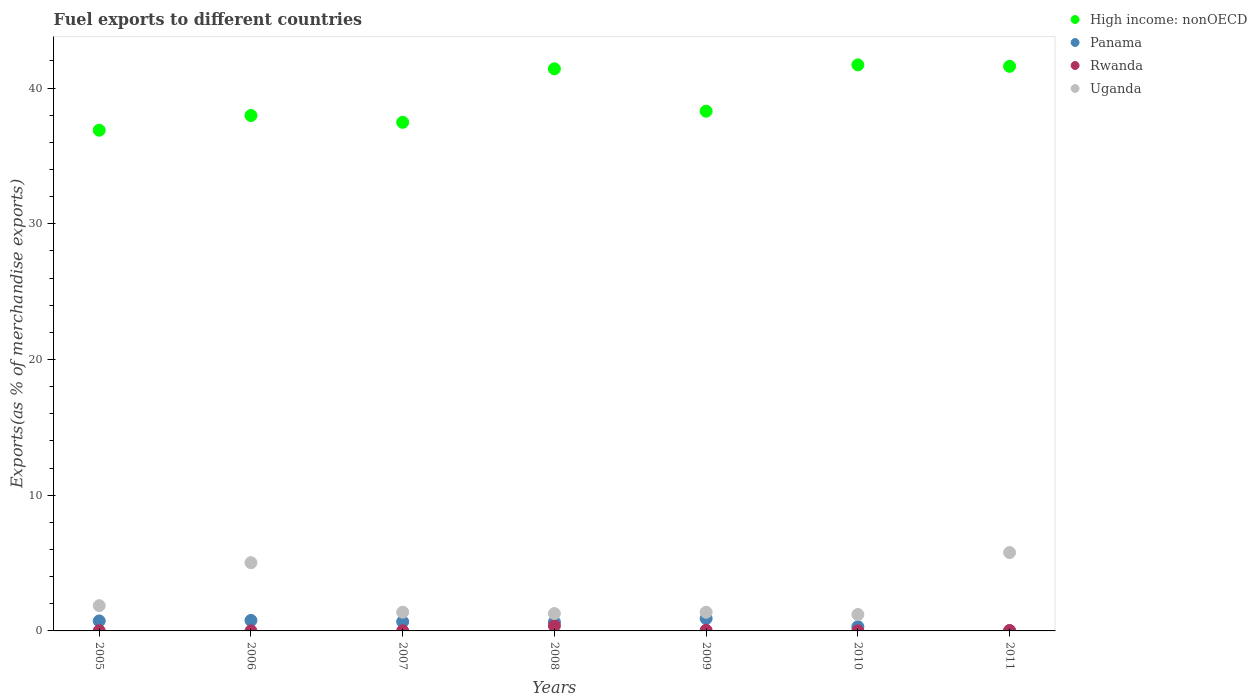What is the percentage of exports to different countries in Uganda in 2005?
Ensure brevity in your answer.  1.86. Across all years, what is the maximum percentage of exports to different countries in High income: nonOECD?
Provide a short and direct response. 41.71. Across all years, what is the minimum percentage of exports to different countries in Panama?
Give a very brief answer. 0.01. In which year was the percentage of exports to different countries in Panama maximum?
Offer a terse response. 2009. In which year was the percentage of exports to different countries in Rwanda minimum?
Provide a succinct answer. 2006. What is the total percentage of exports to different countries in Panama in the graph?
Offer a very short reply. 4.08. What is the difference between the percentage of exports to different countries in Panama in 2005 and that in 2006?
Offer a terse response. -0.04. What is the difference between the percentage of exports to different countries in High income: nonOECD in 2005 and the percentage of exports to different countries in Uganda in 2007?
Offer a terse response. 35.51. What is the average percentage of exports to different countries in Uganda per year?
Offer a very short reply. 2.56. In the year 2009, what is the difference between the percentage of exports to different countries in Panama and percentage of exports to different countries in Uganda?
Make the answer very short. -0.46. In how many years, is the percentage of exports to different countries in High income: nonOECD greater than 20 %?
Provide a succinct answer. 7. What is the ratio of the percentage of exports to different countries in Rwanda in 2007 to that in 2011?
Offer a terse response. 0.36. What is the difference between the highest and the second highest percentage of exports to different countries in Uganda?
Keep it short and to the point. 0.74. What is the difference between the highest and the lowest percentage of exports to different countries in High income: nonOECD?
Your response must be concise. 4.82. In how many years, is the percentage of exports to different countries in Rwanda greater than the average percentage of exports to different countries in Rwanda taken over all years?
Give a very brief answer. 1. Is the sum of the percentage of exports to different countries in High income: nonOECD in 2007 and 2011 greater than the maximum percentage of exports to different countries in Panama across all years?
Offer a terse response. Yes. Is it the case that in every year, the sum of the percentage of exports to different countries in Uganda and percentage of exports to different countries in High income: nonOECD  is greater than the sum of percentage of exports to different countries in Rwanda and percentage of exports to different countries in Panama?
Give a very brief answer. Yes. Does the percentage of exports to different countries in Panama monotonically increase over the years?
Provide a succinct answer. No. Is the percentage of exports to different countries in Rwanda strictly greater than the percentage of exports to different countries in High income: nonOECD over the years?
Your answer should be very brief. No. Is the percentage of exports to different countries in Uganda strictly less than the percentage of exports to different countries in Rwanda over the years?
Offer a very short reply. No. How many years are there in the graph?
Keep it short and to the point. 7. What is the difference between two consecutive major ticks on the Y-axis?
Provide a succinct answer. 10. Are the values on the major ticks of Y-axis written in scientific E-notation?
Make the answer very short. No. Does the graph contain any zero values?
Provide a short and direct response. No. How are the legend labels stacked?
Offer a very short reply. Vertical. What is the title of the graph?
Provide a succinct answer. Fuel exports to different countries. Does "St. Lucia" appear as one of the legend labels in the graph?
Give a very brief answer. No. What is the label or title of the X-axis?
Your response must be concise. Years. What is the label or title of the Y-axis?
Give a very brief answer. Exports(as % of merchandise exports). What is the Exports(as % of merchandise exports) of High income: nonOECD in 2005?
Make the answer very short. 36.89. What is the Exports(as % of merchandise exports) of Panama in 2005?
Give a very brief answer. 0.74. What is the Exports(as % of merchandise exports) in Rwanda in 2005?
Make the answer very short. 0.01. What is the Exports(as % of merchandise exports) of Uganda in 2005?
Offer a terse response. 1.86. What is the Exports(as % of merchandise exports) of High income: nonOECD in 2006?
Offer a terse response. 37.98. What is the Exports(as % of merchandise exports) in Panama in 2006?
Your answer should be compact. 0.77. What is the Exports(as % of merchandise exports) in Rwanda in 2006?
Offer a terse response. 0. What is the Exports(as % of merchandise exports) in Uganda in 2006?
Keep it short and to the point. 5.03. What is the Exports(as % of merchandise exports) in High income: nonOECD in 2007?
Your response must be concise. 37.48. What is the Exports(as % of merchandise exports) of Panama in 2007?
Provide a short and direct response. 0.68. What is the Exports(as % of merchandise exports) in Rwanda in 2007?
Your response must be concise. 0.01. What is the Exports(as % of merchandise exports) in Uganda in 2007?
Make the answer very short. 1.38. What is the Exports(as % of merchandise exports) in High income: nonOECD in 2008?
Keep it short and to the point. 41.42. What is the Exports(as % of merchandise exports) of Panama in 2008?
Offer a very short reply. 0.65. What is the Exports(as % of merchandise exports) of Rwanda in 2008?
Provide a succinct answer. 0.37. What is the Exports(as % of merchandise exports) in Uganda in 2008?
Keep it short and to the point. 1.28. What is the Exports(as % of merchandise exports) of High income: nonOECD in 2009?
Provide a succinct answer. 38.29. What is the Exports(as % of merchandise exports) of Panama in 2009?
Your answer should be very brief. 0.91. What is the Exports(as % of merchandise exports) in Rwanda in 2009?
Ensure brevity in your answer.  0.05. What is the Exports(as % of merchandise exports) of Uganda in 2009?
Keep it short and to the point. 1.38. What is the Exports(as % of merchandise exports) of High income: nonOECD in 2010?
Give a very brief answer. 41.71. What is the Exports(as % of merchandise exports) in Panama in 2010?
Provide a short and direct response. 0.31. What is the Exports(as % of merchandise exports) of Rwanda in 2010?
Keep it short and to the point. 0.01. What is the Exports(as % of merchandise exports) of Uganda in 2010?
Ensure brevity in your answer.  1.21. What is the Exports(as % of merchandise exports) of High income: nonOECD in 2011?
Your answer should be compact. 41.6. What is the Exports(as % of merchandise exports) of Panama in 2011?
Provide a short and direct response. 0.01. What is the Exports(as % of merchandise exports) in Rwanda in 2011?
Provide a succinct answer. 0.03. What is the Exports(as % of merchandise exports) in Uganda in 2011?
Ensure brevity in your answer.  5.77. Across all years, what is the maximum Exports(as % of merchandise exports) in High income: nonOECD?
Provide a short and direct response. 41.71. Across all years, what is the maximum Exports(as % of merchandise exports) in Panama?
Your response must be concise. 0.91. Across all years, what is the maximum Exports(as % of merchandise exports) of Rwanda?
Your response must be concise. 0.37. Across all years, what is the maximum Exports(as % of merchandise exports) of Uganda?
Ensure brevity in your answer.  5.77. Across all years, what is the minimum Exports(as % of merchandise exports) of High income: nonOECD?
Your answer should be very brief. 36.89. Across all years, what is the minimum Exports(as % of merchandise exports) in Panama?
Provide a succinct answer. 0.01. Across all years, what is the minimum Exports(as % of merchandise exports) of Rwanda?
Provide a succinct answer. 0. Across all years, what is the minimum Exports(as % of merchandise exports) in Uganda?
Give a very brief answer. 1.21. What is the total Exports(as % of merchandise exports) of High income: nonOECD in the graph?
Offer a terse response. 275.36. What is the total Exports(as % of merchandise exports) in Panama in the graph?
Your answer should be compact. 4.08. What is the total Exports(as % of merchandise exports) in Rwanda in the graph?
Keep it short and to the point. 0.48. What is the total Exports(as % of merchandise exports) of Uganda in the graph?
Your response must be concise. 17.91. What is the difference between the Exports(as % of merchandise exports) in High income: nonOECD in 2005 and that in 2006?
Offer a terse response. -1.08. What is the difference between the Exports(as % of merchandise exports) in Panama in 2005 and that in 2006?
Give a very brief answer. -0.04. What is the difference between the Exports(as % of merchandise exports) of Rwanda in 2005 and that in 2006?
Provide a short and direct response. 0.01. What is the difference between the Exports(as % of merchandise exports) in Uganda in 2005 and that in 2006?
Offer a very short reply. -3.17. What is the difference between the Exports(as % of merchandise exports) of High income: nonOECD in 2005 and that in 2007?
Offer a very short reply. -0.58. What is the difference between the Exports(as % of merchandise exports) in Panama in 2005 and that in 2007?
Ensure brevity in your answer.  0.06. What is the difference between the Exports(as % of merchandise exports) in Rwanda in 2005 and that in 2007?
Offer a terse response. 0. What is the difference between the Exports(as % of merchandise exports) in Uganda in 2005 and that in 2007?
Make the answer very short. 0.48. What is the difference between the Exports(as % of merchandise exports) in High income: nonOECD in 2005 and that in 2008?
Your answer should be compact. -4.52. What is the difference between the Exports(as % of merchandise exports) in Panama in 2005 and that in 2008?
Make the answer very short. 0.09. What is the difference between the Exports(as % of merchandise exports) of Rwanda in 2005 and that in 2008?
Provide a short and direct response. -0.36. What is the difference between the Exports(as % of merchandise exports) of Uganda in 2005 and that in 2008?
Your answer should be compact. 0.58. What is the difference between the Exports(as % of merchandise exports) of High income: nonOECD in 2005 and that in 2009?
Offer a very short reply. -1.4. What is the difference between the Exports(as % of merchandise exports) of Panama in 2005 and that in 2009?
Your response must be concise. -0.18. What is the difference between the Exports(as % of merchandise exports) in Rwanda in 2005 and that in 2009?
Provide a succinct answer. -0.03. What is the difference between the Exports(as % of merchandise exports) of Uganda in 2005 and that in 2009?
Your response must be concise. 0.49. What is the difference between the Exports(as % of merchandise exports) of High income: nonOECD in 2005 and that in 2010?
Provide a short and direct response. -4.82. What is the difference between the Exports(as % of merchandise exports) of Panama in 2005 and that in 2010?
Your response must be concise. 0.42. What is the difference between the Exports(as % of merchandise exports) of Rwanda in 2005 and that in 2010?
Make the answer very short. 0.01. What is the difference between the Exports(as % of merchandise exports) of Uganda in 2005 and that in 2010?
Give a very brief answer. 0.65. What is the difference between the Exports(as % of merchandise exports) in High income: nonOECD in 2005 and that in 2011?
Provide a short and direct response. -4.71. What is the difference between the Exports(as % of merchandise exports) of Panama in 2005 and that in 2011?
Offer a very short reply. 0.72. What is the difference between the Exports(as % of merchandise exports) in Rwanda in 2005 and that in 2011?
Provide a short and direct response. -0.02. What is the difference between the Exports(as % of merchandise exports) of Uganda in 2005 and that in 2011?
Keep it short and to the point. -3.91. What is the difference between the Exports(as % of merchandise exports) in High income: nonOECD in 2006 and that in 2007?
Give a very brief answer. 0.5. What is the difference between the Exports(as % of merchandise exports) in Panama in 2006 and that in 2007?
Offer a terse response. 0.09. What is the difference between the Exports(as % of merchandise exports) of Rwanda in 2006 and that in 2007?
Your answer should be very brief. -0.01. What is the difference between the Exports(as % of merchandise exports) in Uganda in 2006 and that in 2007?
Your answer should be very brief. 3.65. What is the difference between the Exports(as % of merchandise exports) of High income: nonOECD in 2006 and that in 2008?
Your answer should be compact. -3.44. What is the difference between the Exports(as % of merchandise exports) of Panama in 2006 and that in 2008?
Your answer should be very brief. 0.12. What is the difference between the Exports(as % of merchandise exports) in Rwanda in 2006 and that in 2008?
Keep it short and to the point. -0.37. What is the difference between the Exports(as % of merchandise exports) in Uganda in 2006 and that in 2008?
Provide a succinct answer. 3.75. What is the difference between the Exports(as % of merchandise exports) in High income: nonOECD in 2006 and that in 2009?
Provide a succinct answer. -0.32. What is the difference between the Exports(as % of merchandise exports) in Panama in 2006 and that in 2009?
Your response must be concise. -0.14. What is the difference between the Exports(as % of merchandise exports) of Rwanda in 2006 and that in 2009?
Keep it short and to the point. -0.04. What is the difference between the Exports(as % of merchandise exports) of Uganda in 2006 and that in 2009?
Your answer should be compact. 3.65. What is the difference between the Exports(as % of merchandise exports) in High income: nonOECD in 2006 and that in 2010?
Your answer should be compact. -3.73. What is the difference between the Exports(as % of merchandise exports) in Panama in 2006 and that in 2010?
Offer a very short reply. 0.46. What is the difference between the Exports(as % of merchandise exports) in Rwanda in 2006 and that in 2010?
Provide a succinct answer. -0. What is the difference between the Exports(as % of merchandise exports) of Uganda in 2006 and that in 2010?
Provide a short and direct response. 3.82. What is the difference between the Exports(as % of merchandise exports) in High income: nonOECD in 2006 and that in 2011?
Your answer should be compact. -3.62. What is the difference between the Exports(as % of merchandise exports) of Panama in 2006 and that in 2011?
Your answer should be very brief. 0.76. What is the difference between the Exports(as % of merchandise exports) of Rwanda in 2006 and that in 2011?
Make the answer very short. -0.03. What is the difference between the Exports(as % of merchandise exports) of Uganda in 2006 and that in 2011?
Your response must be concise. -0.74. What is the difference between the Exports(as % of merchandise exports) of High income: nonOECD in 2007 and that in 2008?
Your answer should be compact. -3.94. What is the difference between the Exports(as % of merchandise exports) of Panama in 2007 and that in 2008?
Offer a terse response. 0.03. What is the difference between the Exports(as % of merchandise exports) in Rwanda in 2007 and that in 2008?
Make the answer very short. -0.36. What is the difference between the Exports(as % of merchandise exports) in Uganda in 2007 and that in 2008?
Your response must be concise. 0.1. What is the difference between the Exports(as % of merchandise exports) of High income: nonOECD in 2007 and that in 2009?
Keep it short and to the point. -0.82. What is the difference between the Exports(as % of merchandise exports) in Panama in 2007 and that in 2009?
Provide a short and direct response. -0.23. What is the difference between the Exports(as % of merchandise exports) in Rwanda in 2007 and that in 2009?
Keep it short and to the point. -0.04. What is the difference between the Exports(as % of merchandise exports) of Uganda in 2007 and that in 2009?
Keep it short and to the point. 0. What is the difference between the Exports(as % of merchandise exports) of High income: nonOECD in 2007 and that in 2010?
Make the answer very short. -4.23. What is the difference between the Exports(as % of merchandise exports) of Panama in 2007 and that in 2010?
Offer a very short reply. 0.37. What is the difference between the Exports(as % of merchandise exports) in Rwanda in 2007 and that in 2010?
Offer a very short reply. 0.01. What is the difference between the Exports(as % of merchandise exports) of Uganda in 2007 and that in 2010?
Your answer should be very brief. 0.17. What is the difference between the Exports(as % of merchandise exports) in High income: nonOECD in 2007 and that in 2011?
Your response must be concise. -4.12. What is the difference between the Exports(as % of merchandise exports) of Panama in 2007 and that in 2011?
Give a very brief answer. 0.67. What is the difference between the Exports(as % of merchandise exports) in Rwanda in 2007 and that in 2011?
Your response must be concise. -0.02. What is the difference between the Exports(as % of merchandise exports) in Uganda in 2007 and that in 2011?
Offer a very short reply. -4.39. What is the difference between the Exports(as % of merchandise exports) of High income: nonOECD in 2008 and that in 2009?
Offer a terse response. 3.12. What is the difference between the Exports(as % of merchandise exports) in Panama in 2008 and that in 2009?
Ensure brevity in your answer.  -0.26. What is the difference between the Exports(as % of merchandise exports) of Rwanda in 2008 and that in 2009?
Your answer should be very brief. 0.33. What is the difference between the Exports(as % of merchandise exports) of Uganda in 2008 and that in 2009?
Offer a very short reply. -0.1. What is the difference between the Exports(as % of merchandise exports) of High income: nonOECD in 2008 and that in 2010?
Give a very brief answer. -0.29. What is the difference between the Exports(as % of merchandise exports) in Panama in 2008 and that in 2010?
Your answer should be very brief. 0.34. What is the difference between the Exports(as % of merchandise exports) of Rwanda in 2008 and that in 2010?
Keep it short and to the point. 0.37. What is the difference between the Exports(as % of merchandise exports) of Uganda in 2008 and that in 2010?
Keep it short and to the point. 0.07. What is the difference between the Exports(as % of merchandise exports) in High income: nonOECD in 2008 and that in 2011?
Your answer should be very brief. -0.18. What is the difference between the Exports(as % of merchandise exports) in Panama in 2008 and that in 2011?
Your answer should be compact. 0.64. What is the difference between the Exports(as % of merchandise exports) in Rwanda in 2008 and that in 2011?
Offer a very short reply. 0.34. What is the difference between the Exports(as % of merchandise exports) in Uganda in 2008 and that in 2011?
Make the answer very short. -4.49. What is the difference between the Exports(as % of merchandise exports) of High income: nonOECD in 2009 and that in 2010?
Give a very brief answer. -3.41. What is the difference between the Exports(as % of merchandise exports) of Panama in 2009 and that in 2010?
Offer a very short reply. 0.6. What is the difference between the Exports(as % of merchandise exports) in Rwanda in 2009 and that in 2010?
Make the answer very short. 0.04. What is the difference between the Exports(as % of merchandise exports) in Uganda in 2009 and that in 2010?
Give a very brief answer. 0.17. What is the difference between the Exports(as % of merchandise exports) in High income: nonOECD in 2009 and that in 2011?
Make the answer very short. -3.31. What is the difference between the Exports(as % of merchandise exports) in Panama in 2009 and that in 2011?
Your answer should be very brief. 0.9. What is the difference between the Exports(as % of merchandise exports) of Rwanda in 2009 and that in 2011?
Provide a short and direct response. 0.02. What is the difference between the Exports(as % of merchandise exports) in Uganda in 2009 and that in 2011?
Give a very brief answer. -4.4. What is the difference between the Exports(as % of merchandise exports) of High income: nonOECD in 2010 and that in 2011?
Keep it short and to the point. 0.11. What is the difference between the Exports(as % of merchandise exports) in Panama in 2010 and that in 2011?
Offer a terse response. 0.3. What is the difference between the Exports(as % of merchandise exports) of Rwanda in 2010 and that in 2011?
Make the answer very short. -0.03. What is the difference between the Exports(as % of merchandise exports) in Uganda in 2010 and that in 2011?
Provide a succinct answer. -4.56. What is the difference between the Exports(as % of merchandise exports) of High income: nonOECD in 2005 and the Exports(as % of merchandise exports) of Panama in 2006?
Your response must be concise. 36.12. What is the difference between the Exports(as % of merchandise exports) in High income: nonOECD in 2005 and the Exports(as % of merchandise exports) in Rwanda in 2006?
Your response must be concise. 36.89. What is the difference between the Exports(as % of merchandise exports) in High income: nonOECD in 2005 and the Exports(as % of merchandise exports) in Uganda in 2006?
Make the answer very short. 31.86. What is the difference between the Exports(as % of merchandise exports) in Panama in 2005 and the Exports(as % of merchandise exports) in Rwanda in 2006?
Provide a short and direct response. 0.73. What is the difference between the Exports(as % of merchandise exports) of Panama in 2005 and the Exports(as % of merchandise exports) of Uganda in 2006?
Keep it short and to the point. -4.29. What is the difference between the Exports(as % of merchandise exports) in Rwanda in 2005 and the Exports(as % of merchandise exports) in Uganda in 2006?
Make the answer very short. -5.02. What is the difference between the Exports(as % of merchandise exports) in High income: nonOECD in 2005 and the Exports(as % of merchandise exports) in Panama in 2007?
Give a very brief answer. 36.21. What is the difference between the Exports(as % of merchandise exports) of High income: nonOECD in 2005 and the Exports(as % of merchandise exports) of Rwanda in 2007?
Offer a very short reply. 36.88. What is the difference between the Exports(as % of merchandise exports) in High income: nonOECD in 2005 and the Exports(as % of merchandise exports) in Uganda in 2007?
Your response must be concise. 35.51. What is the difference between the Exports(as % of merchandise exports) in Panama in 2005 and the Exports(as % of merchandise exports) in Rwanda in 2007?
Your response must be concise. 0.73. What is the difference between the Exports(as % of merchandise exports) of Panama in 2005 and the Exports(as % of merchandise exports) of Uganda in 2007?
Your answer should be very brief. -0.64. What is the difference between the Exports(as % of merchandise exports) in Rwanda in 2005 and the Exports(as % of merchandise exports) in Uganda in 2007?
Offer a terse response. -1.37. What is the difference between the Exports(as % of merchandise exports) in High income: nonOECD in 2005 and the Exports(as % of merchandise exports) in Panama in 2008?
Your answer should be compact. 36.24. What is the difference between the Exports(as % of merchandise exports) of High income: nonOECD in 2005 and the Exports(as % of merchandise exports) of Rwanda in 2008?
Your response must be concise. 36.52. What is the difference between the Exports(as % of merchandise exports) of High income: nonOECD in 2005 and the Exports(as % of merchandise exports) of Uganda in 2008?
Keep it short and to the point. 35.61. What is the difference between the Exports(as % of merchandise exports) of Panama in 2005 and the Exports(as % of merchandise exports) of Rwanda in 2008?
Give a very brief answer. 0.36. What is the difference between the Exports(as % of merchandise exports) in Panama in 2005 and the Exports(as % of merchandise exports) in Uganda in 2008?
Your response must be concise. -0.54. What is the difference between the Exports(as % of merchandise exports) in Rwanda in 2005 and the Exports(as % of merchandise exports) in Uganda in 2008?
Make the answer very short. -1.27. What is the difference between the Exports(as % of merchandise exports) in High income: nonOECD in 2005 and the Exports(as % of merchandise exports) in Panama in 2009?
Provide a succinct answer. 35.98. What is the difference between the Exports(as % of merchandise exports) in High income: nonOECD in 2005 and the Exports(as % of merchandise exports) in Rwanda in 2009?
Your response must be concise. 36.84. What is the difference between the Exports(as % of merchandise exports) in High income: nonOECD in 2005 and the Exports(as % of merchandise exports) in Uganda in 2009?
Your answer should be compact. 35.52. What is the difference between the Exports(as % of merchandise exports) in Panama in 2005 and the Exports(as % of merchandise exports) in Rwanda in 2009?
Give a very brief answer. 0.69. What is the difference between the Exports(as % of merchandise exports) of Panama in 2005 and the Exports(as % of merchandise exports) of Uganda in 2009?
Your answer should be compact. -0.64. What is the difference between the Exports(as % of merchandise exports) of Rwanda in 2005 and the Exports(as % of merchandise exports) of Uganda in 2009?
Your response must be concise. -1.36. What is the difference between the Exports(as % of merchandise exports) of High income: nonOECD in 2005 and the Exports(as % of merchandise exports) of Panama in 2010?
Your answer should be very brief. 36.58. What is the difference between the Exports(as % of merchandise exports) in High income: nonOECD in 2005 and the Exports(as % of merchandise exports) in Rwanda in 2010?
Your response must be concise. 36.89. What is the difference between the Exports(as % of merchandise exports) in High income: nonOECD in 2005 and the Exports(as % of merchandise exports) in Uganda in 2010?
Provide a succinct answer. 35.68. What is the difference between the Exports(as % of merchandise exports) in Panama in 2005 and the Exports(as % of merchandise exports) in Rwanda in 2010?
Make the answer very short. 0.73. What is the difference between the Exports(as % of merchandise exports) in Panama in 2005 and the Exports(as % of merchandise exports) in Uganda in 2010?
Provide a succinct answer. -0.47. What is the difference between the Exports(as % of merchandise exports) of Rwanda in 2005 and the Exports(as % of merchandise exports) of Uganda in 2010?
Your response must be concise. -1.2. What is the difference between the Exports(as % of merchandise exports) of High income: nonOECD in 2005 and the Exports(as % of merchandise exports) of Panama in 2011?
Provide a succinct answer. 36.88. What is the difference between the Exports(as % of merchandise exports) of High income: nonOECD in 2005 and the Exports(as % of merchandise exports) of Rwanda in 2011?
Your answer should be compact. 36.86. What is the difference between the Exports(as % of merchandise exports) of High income: nonOECD in 2005 and the Exports(as % of merchandise exports) of Uganda in 2011?
Provide a succinct answer. 31.12. What is the difference between the Exports(as % of merchandise exports) of Panama in 2005 and the Exports(as % of merchandise exports) of Rwanda in 2011?
Offer a very short reply. 0.71. What is the difference between the Exports(as % of merchandise exports) in Panama in 2005 and the Exports(as % of merchandise exports) in Uganda in 2011?
Ensure brevity in your answer.  -5.04. What is the difference between the Exports(as % of merchandise exports) in Rwanda in 2005 and the Exports(as % of merchandise exports) in Uganda in 2011?
Your answer should be very brief. -5.76. What is the difference between the Exports(as % of merchandise exports) of High income: nonOECD in 2006 and the Exports(as % of merchandise exports) of Panama in 2007?
Make the answer very short. 37.3. What is the difference between the Exports(as % of merchandise exports) of High income: nonOECD in 2006 and the Exports(as % of merchandise exports) of Rwanda in 2007?
Provide a short and direct response. 37.97. What is the difference between the Exports(as % of merchandise exports) in High income: nonOECD in 2006 and the Exports(as % of merchandise exports) in Uganda in 2007?
Offer a terse response. 36.6. What is the difference between the Exports(as % of merchandise exports) in Panama in 2006 and the Exports(as % of merchandise exports) in Rwanda in 2007?
Offer a very short reply. 0.76. What is the difference between the Exports(as % of merchandise exports) of Panama in 2006 and the Exports(as % of merchandise exports) of Uganda in 2007?
Offer a very short reply. -0.61. What is the difference between the Exports(as % of merchandise exports) in Rwanda in 2006 and the Exports(as % of merchandise exports) in Uganda in 2007?
Offer a terse response. -1.38. What is the difference between the Exports(as % of merchandise exports) of High income: nonOECD in 2006 and the Exports(as % of merchandise exports) of Panama in 2008?
Your answer should be compact. 37.33. What is the difference between the Exports(as % of merchandise exports) in High income: nonOECD in 2006 and the Exports(as % of merchandise exports) in Rwanda in 2008?
Keep it short and to the point. 37.6. What is the difference between the Exports(as % of merchandise exports) in High income: nonOECD in 2006 and the Exports(as % of merchandise exports) in Uganda in 2008?
Make the answer very short. 36.7. What is the difference between the Exports(as % of merchandise exports) of Panama in 2006 and the Exports(as % of merchandise exports) of Rwanda in 2008?
Provide a short and direct response. 0.4. What is the difference between the Exports(as % of merchandise exports) in Panama in 2006 and the Exports(as % of merchandise exports) in Uganda in 2008?
Make the answer very short. -0.51. What is the difference between the Exports(as % of merchandise exports) in Rwanda in 2006 and the Exports(as % of merchandise exports) in Uganda in 2008?
Give a very brief answer. -1.28. What is the difference between the Exports(as % of merchandise exports) in High income: nonOECD in 2006 and the Exports(as % of merchandise exports) in Panama in 2009?
Your answer should be very brief. 37.06. What is the difference between the Exports(as % of merchandise exports) in High income: nonOECD in 2006 and the Exports(as % of merchandise exports) in Rwanda in 2009?
Make the answer very short. 37.93. What is the difference between the Exports(as % of merchandise exports) in High income: nonOECD in 2006 and the Exports(as % of merchandise exports) in Uganda in 2009?
Provide a short and direct response. 36.6. What is the difference between the Exports(as % of merchandise exports) in Panama in 2006 and the Exports(as % of merchandise exports) in Rwanda in 2009?
Offer a terse response. 0.73. What is the difference between the Exports(as % of merchandise exports) of Panama in 2006 and the Exports(as % of merchandise exports) of Uganda in 2009?
Offer a very short reply. -0.6. What is the difference between the Exports(as % of merchandise exports) of Rwanda in 2006 and the Exports(as % of merchandise exports) of Uganda in 2009?
Keep it short and to the point. -1.37. What is the difference between the Exports(as % of merchandise exports) in High income: nonOECD in 2006 and the Exports(as % of merchandise exports) in Panama in 2010?
Offer a terse response. 37.66. What is the difference between the Exports(as % of merchandise exports) of High income: nonOECD in 2006 and the Exports(as % of merchandise exports) of Rwanda in 2010?
Give a very brief answer. 37.97. What is the difference between the Exports(as % of merchandise exports) in High income: nonOECD in 2006 and the Exports(as % of merchandise exports) in Uganda in 2010?
Provide a succinct answer. 36.77. What is the difference between the Exports(as % of merchandise exports) of Panama in 2006 and the Exports(as % of merchandise exports) of Rwanda in 2010?
Your answer should be compact. 0.77. What is the difference between the Exports(as % of merchandise exports) of Panama in 2006 and the Exports(as % of merchandise exports) of Uganda in 2010?
Ensure brevity in your answer.  -0.44. What is the difference between the Exports(as % of merchandise exports) of Rwanda in 2006 and the Exports(as % of merchandise exports) of Uganda in 2010?
Provide a short and direct response. -1.21. What is the difference between the Exports(as % of merchandise exports) in High income: nonOECD in 2006 and the Exports(as % of merchandise exports) in Panama in 2011?
Offer a terse response. 37.96. What is the difference between the Exports(as % of merchandise exports) of High income: nonOECD in 2006 and the Exports(as % of merchandise exports) of Rwanda in 2011?
Your answer should be very brief. 37.95. What is the difference between the Exports(as % of merchandise exports) of High income: nonOECD in 2006 and the Exports(as % of merchandise exports) of Uganda in 2011?
Keep it short and to the point. 32.2. What is the difference between the Exports(as % of merchandise exports) in Panama in 2006 and the Exports(as % of merchandise exports) in Rwanda in 2011?
Offer a very short reply. 0.74. What is the difference between the Exports(as % of merchandise exports) in Panama in 2006 and the Exports(as % of merchandise exports) in Uganda in 2011?
Keep it short and to the point. -5. What is the difference between the Exports(as % of merchandise exports) in Rwanda in 2006 and the Exports(as % of merchandise exports) in Uganda in 2011?
Your response must be concise. -5.77. What is the difference between the Exports(as % of merchandise exports) in High income: nonOECD in 2007 and the Exports(as % of merchandise exports) in Panama in 2008?
Ensure brevity in your answer.  36.83. What is the difference between the Exports(as % of merchandise exports) of High income: nonOECD in 2007 and the Exports(as % of merchandise exports) of Rwanda in 2008?
Give a very brief answer. 37.1. What is the difference between the Exports(as % of merchandise exports) in High income: nonOECD in 2007 and the Exports(as % of merchandise exports) in Uganda in 2008?
Your response must be concise. 36.2. What is the difference between the Exports(as % of merchandise exports) in Panama in 2007 and the Exports(as % of merchandise exports) in Rwanda in 2008?
Ensure brevity in your answer.  0.31. What is the difference between the Exports(as % of merchandise exports) of Panama in 2007 and the Exports(as % of merchandise exports) of Uganda in 2008?
Provide a succinct answer. -0.6. What is the difference between the Exports(as % of merchandise exports) of Rwanda in 2007 and the Exports(as % of merchandise exports) of Uganda in 2008?
Provide a short and direct response. -1.27. What is the difference between the Exports(as % of merchandise exports) of High income: nonOECD in 2007 and the Exports(as % of merchandise exports) of Panama in 2009?
Ensure brevity in your answer.  36.56. What is the difference between the Exports(as % of merchandise exports) of High income: nonOECD in 2007 and the Exports(as % of merchandise exports) of Rwanda in 2009?
Give a very brief answer. 37.43. What is the difference between the Exports(as % of merchandise exports) in High income: nonOECD in 2007 and the Exports(as % of merchandise exports) in Uganda in 2009?
Provide a succinct answer. 36.1. What is the difference between the Exports(as % of merchandise exports) in Panama in 2007 and the Exports(as % of merchandise exports) in Rwanda in 2009?
Keep it short and to the point. 0.63. What is the difference between the Exports(as % of merchandise exports) of Panama in 2007 and the Exports(as % of merchandise exports) of Uganda in 2009?
Provide a short and direct response. -0.69. What is the difference between the Exports(as % of merchandise exports) in Rwanda in 2007 and the Exports(as % of merchandise exports) in Uganda in 2009?
Your answer should be compact. -1.36. What is the difference between the Exports(as % of merchandise exports) in High income: nonOECD in 2007 and the Exports(as % of merchandise exports) in Panama in 2010?
Provide a short and direct response. 37.16. What is the difference between the Exports(as % of merchandise exports) of High income: nonOECD in 2007 and the Exports(as % of merchandise exports) of Rwanda in 2010?
Make the answer very short. 37.47. What is the difference between the Exports(as % of merchandise exports) in High income: nonOECD in 2007 and the Exports(as % of merchandise exports) in Uganda in 2010?
Keep it short and to the point. 36.27. What is the difference between the Exports(as % of merchandise exports) of Panama in 2007 and the Exports(as % of merchandise exports) of Rwanda in 2010?
Give a very brief answer. 0.68. What is the difference between the Exports(as % of merchandise exports) of Panama in 2007 and the Exports(as % of merchandise exports) of Uganda in 2010?
Ensure brevity in your answer.  -0.53. What is the difference between the Exports(as % of merchandise exports) of Rwanda in 2007 and the Exports(as % of merchandise exports) of Uganda in 2010?
Make the answer very short. -1.2. What is the difference between the Exports(as % of merchandise exports) in High income: nonOECD in 2007 and the Exports(as % of merchandise exports) in Panama in 2011?
Provide a short and direct response. 37.46. What is the difference between the Exports(as % of merchandise exports) of High income: nonOECD in 2007 and the Exports(as % of merchandise exports) of Rwanda in 2011?
Provide a succinct answer. 37.45. What is the difference between the Exports(as % of merchandise exports) in High income: nonOECD in 2007 and the Exports(as % of merchandise exports) in Uganda in 2011?
Make the answer very short. 31.7. What is the difference between the Exports(as % of merchandise exports) of Panama in 2007 and the Exports(as % of merchandise exports) of Rwanda in 2011?
Your response must be concise. 0.65. What is the difference between the Exports(as % of merchandise exports) in Panama in 2007 and the Exports(as % of merchandise exports) in Uganda in 2011?
Ensure brevity in your answer.  -5.09. What is the difference between the Exports(as % of merchandise exports) in Rwanda in 2007 and the Exports(as % of merchandise exports) in Uganda in 2011?
Offer a terse response. -5.76. What is the difference between the Exports(as % of merchandise exports) of High income: nonOECD in 2008 and the Exports(as % of merchandise exports) of Panama in 2009?
Offer a terse response. 40.5. What is the difference between the Exports(as % of merchandise exports) in High income: nonOECD in 2008 and the Exports(as % of merchandise exports) in Rwanda in 2009?
Your answer should be very brief. 41.37. What is the difference between the Exports(as % of merchandise exports) in High income: nonOECD in 2008 and the Exports(as % of merchandise exports) in Uganda in 2009?
Keep it short and to the point. 40.04. What is the difference between the Exports(as % of merchandise exports) of Panama in 2008 and the Exports(as % of merchandise exports) of Rwanda in 2009?
Your answer should be compact. 0.6. What is the difference between the Exports(as % of merchandise exports) of Panama in 2008 and the Exports(as % of merchandise exports) of Uganda in 2009?
Your answer should be very brief. -0.73. What is the difference between the Exports(as % of merchandise exports) in Rwanda in 2008 and the Exports(as % of merchandise exports) in Uganda in 2009?
Provide a short and direct response. -1. What is the difference between the Exports(as % of merchandise exports) in High income: nonOECD in 2008 and the Exports(as % of merchandise exports) in Panama in 2010?
Provide a short and direct response. 41.1. What is the difference between the Exports(as % of merchandise exports) in High income: nonOECD in 2008 and the Exports(as % of merchandise exports) in Rwanda in 2010?
Make the answer very short. 41.41. What is the difference between the Exports(as % of merchandise exports) in High income: nonOECD in 2008 and the Exports(as % of merchandise exports) in Uganda in 2010?
Your answer should be very brief. 40.21. What is the difference between the Exports(as % of merchandise exports) of Panama in 2008 and the Exports(as % of merchandise exports) of Rwanda in 2010?
Your answer should be compact. 0.64. What is the difference between the Exports(as % of merchandise exports) of Panama in 2008 and the Exports(as % of merchandise exports) of Uganda in 2010?
Provide a short and direct response. -0.56. What is the difference between the Exports(as % of merchandise exports) in Rwanda in 2008 and the Exports(as % of merchandise exports) in Uganda in 2010?
Provide a short and direct response. -0.84. What is the difference between the Exports(as % of merchandise exports) of High income: nonOECD in 2008 and the Exports(as % of merchandise exports) of Panama in 2011?
Keep it short and to the point. 41.4. What is the difference between the Exports(as % of merchandise exports) of High income: nonOECD in 2008 and the Exports(as % of merchandise exports) of Rwanda in 2011?
Your answer should be very brief. 41.39. What is the difference between the Exports(as % of merchandise exports) in High income: nonOECD in 2008 and the Exports(as % of merchandise exports) in Uganda in 2011?
Provide a succinct answer. 35.64. What is the difference between the Exports(as % of merchandise exports) in Panama in 2008 and the Exports(as % of merchandise exports) in Rwanda in 2011?
Your response must be concise. 0.62. What is the difference between the Exports(as % of merchandise exports) in Panama in 2008 and the Exports(as % of merchandise exports) in Uganda in 2011?
Keep it short and to the point. -5.12. What is the difference between the Exports(as % of merchandise exports) of Rwanda in 2008 and the Exports(as % of merchandise exports) of Uganda in 2011?
Your answer should be very brief. -5.4. What is the difference between the Exports(as % of merchandise exports) in High income: nonOECD in 2009 and the Exports(as % of merchandise exports) in Panama in 2010?
Provide a succinct answer. 37.98. What is the difference between the Exports(as % of merchandise exports) of High income: nonOECD in 2009 and the Exports(as % of merchandise exports) of Rwanda in 2010?
Offer a very short reply. 38.29. What is the difference between the Exports(as % of merchandise exports) of High income: nonOECD in 2009 and the Exports(as % of merchandise exports) of Uganda in 2010?
Ensure brevity in your answer.  37.08. What is the difference between the Exports(as % of merchandise exports) in Panama in 2009 and the Exports(as % of merchandise exports) in Rwanda in 2010?
Make the answer very short. 0.91. What is the difference between the Exports(as % of merchandise exports) in Panama in 2009 and the Exports(as % of merchandise exports) in Uganda in 2010?
Give a very brief answer. -0.3. What is the difference between the Exports(as % of merchandise exports) in Rwanda in 2009 and the Exports(as % of merchandise exports) in Uganda in 2010?
Make the answer very short. -1.16. What is the difference between the Exports(as % of merchandise exports) of High income: nonOECD in 2009 and the Exports(as % of merchandise exports) of Panama in 2011?
Offer a terse response. 38.28. What is the difference between the Exports(as % of merchandise exports) of High income: nonOECD in 2009 and the Exports(as % of merchandise exports) of Rwanda in 2011?
Offer a very short reply. 38.26. What is the difference between the Exports(as % of merchandise exports) in High income: nonOECD in 2009 and the Exports(as % of merchandise exports) in Uganda in 2011?
Ensure brevity in your answer.  32.52. What is the difference between the Exports(as % of merchandise exports) in Panama in 2009 and the Exports(as % of merchandise exports) in Rwanda in 2011?
Your answer should be compact. 0.88. What is the difference between the Exports(as % of merchandise exports) in Panama in 2009 and the Exports(as % of merchandise exports) in Uganda in 2011?
Provide a short and direct response. -4.86. What is the difference between the Exports(as % of merchandise exports) in Rwanda in 2009 and the Exports(as % of merchandise exports) in Uganda in 2011?
Provide a succinct answer. -5.73. What is the difference between the Exports(as % of merchandise exports) of High income: nonOECD in 2010 and the Exports(as % of merchandise exports) of Panama in 2011?
Your answer should be compact. 41.69. What is the difference between the Exports(as % of merchandise exports) in High income: nonOECD in 2010 and the Exports(as % of merchandise exports) in Rwanda in 2011?
Offer a terse response. 41.68. What is the difference between the Exports(as % of merchandise exports) in High income: nonOECD in 2010 and the Exports(as % of merchandise exports) in Uganda in 2011?
Give a very brief answer. 35.93. What is the difference between the Exports(as % of merchandise exports) in Panama in 2010 and the Exports(as % of merchandise exports) in Rwanda in 2011?
Offer a terse response. 0.28. What is the difference between the Exports(as % of merchandise exports) of Panama in 2010 and the Exports(as % of merchandise exports) of Uganda in 2011?
Offer a very short reply. -5.46. What is the difference between the Exports(as % of merchandise exports) in Rwanda in 2010 and the Exports(as % of merchandise exports) in Uganda in 2011?
Offer a very short reply. -5.77. What is the average Exports(as % of merchandise exports) in High income: nonOECD per year?
Offer a terse response. 39.34. What is the average Exports(as % of merchandise exports) of Panama per year?
Your answer should be very brief. 0.58. What is the average Exports(as % of merchandise exports) of Rwanda per year?
Keep it short and to the point. 0.07. What is the average Exports(as % of merchandise exports) of Uganda per year?
Make the answer very short. 2.56. In the year 2005, what is the difference between the Exports(as % of merchandise exports) of High income: nonOECD and Exports(as % of merchandise exports) of Panama?
Give a very brief answer. 36.16. In the year 2005, what is the difference between the Exports(as % of merchandise exports) in High income: nonOECD and Exports(as % of merchandise exports) in Rwanda?
Provide a short and direct response. 36.88. In the year 2005, what is the difference between the Exports(as % of merchandise exports) of High income: nonOECD and Exports(as % of merchandise exports) of Uganda?
Keep it short and to the point. 35.03. In the year 2005, what is the difference between the Exports(as % of merchandise exports) of Panama and Exports(as % of merchandise exports) of Rwanda?
Give a very brief answer. 0.72. In the year 2005, what is the difference between the Exports(as % of merchandise exports) in Panama and Exports(as % of merchandise exports) in Uganda?
Ensure brevity in your answer.  -1.12. In the year 2005, what is the difference between the Exports(as % of merchandise exports) of Rwanda and Exports(as % of merchandise exports) of Uganda?
Give a very brief answer. -1.85. In the year 2006, what is the difference between the Exports(as % of merchandise exports) in High income: nonOECD and Exports(as % of merchandise exports) in Panama?
Provide a short and direct response. 37.2. In the year 2006, what is the difference between the Exports(as % of merchandise exports) in High income: nonOECD and Exports(as % of merchandise exports) in Rwanda?
Offer a very short reply. 37.97. In the year 2006, what is the difference between the Exports(as % of merchandise exports) in High income: nonOECD and Exports(as % of merchandise exports) in Uganda?
Make the answer very short. 32.95. In the year 2006, what is the difference between the Exports(as % of merchandise exports) of Panama and Exports(as % of merchandise exports) of Rwanda?
Keep it short and to the point. 0.77. In the year 2006, what is the difference between the Exports(as % of merchandise exports) of Panama and Exports(as % of merchandise exports) of Uganda?
Keep it short and to the point. -4.25. In the year 2006, what is the difference between the Exports(as % of merchandise exports) in Rwanda and Exports(as % of merchandise exports) in Uganda?
Provide a succinct answer. -5.02. In the year 2007, what is the difference between the Exports(as % of merchandise exports) in High income: nonOECD and Exports(as % of merchandise exports) in Panama?
Offer a terse response. 36.8. In the year 2007, what is the difference between the Exports(as % of merchandise exports) in High income: nonOECD and Exports(as % of merchandise exports) in Rwanda?
Your answer should be compact. 37.46. In the year 2007, what is the difference between the Exports(as % of merchandise exports) in High income: nonOECD and Exports(as % of merchandise exports) in Uganda?
Make the answer very short. 36.1. In the year 2007, what is the difference between the Exports(as % of merchandise exports) in Panama and Exports(as % of merchandise exports) in Rwanda?
Ensure brevity in your answer.  0.67. In the year 2007, what is the difference between the Exports(as % of merchandise exports) of Panama and Exports(as % of merchandise exports) of Uganda?
Ensure brevity in your answer.  -0.7. In the year 2007, what is the difference between the Exports(as % of merchandise exports) in Rwanda and Exports(as % of merchandise exports) in Uganda?
Offer a terse response. -1.37. In the year 2008, what is the difference between the Exports(as % of merchandise exports) in High income: nonOECD and Exports(as % of merchandise exports) in Panama?
Your answer should be compact. 40.77. In the year 2008, what is the difference between the Exports(as % of merchandise exports) of High income: nonOECD and Exports(as % of merchandise exports) of Rwanda?
Make the answer very short. 41.04. In the year 2008, what is the difference between the Exports(as % of merchandise exports) of High income: nonOECD and Exports(as % of merchandise exports) of Uganda?
Offer a terse response. 40.14. In the year 2008, what is the difference between the Exports(as % of merchandise exports) of Panama and Exports(as % of merchandise exports) of Rwanda?
Provide a short and direct response. 0.28. In the year 2008, what is the difference between the Exports(as % of merchandise exports) of Panama and Exports(as % of merchandise exports) of Uganda?
Ensure brevity in your answer.  -0.63. In the year 2008, what is the difference between the Exports(as % of merchandise exports) of Rwanda and Exports(as % of merchandise exports) of Uganda?
Make the answer very short. -0.91. In the year 2009, what is the difference between the Exports(as % of merchandise exports) in High income: nonOECD and Exports(as % of merchandise exports) in Panama?
Keep it short and to the point. 37.38. In the year 2009, what is the difference between the Exports(as % of merchandise exports) in High income: nonOECD and Exports(as % of merchandise exports) in Rwanda?
Ensure brevity in your answer.  38.25. In the year 2009, what is the difference between the Exports(as % of merchandise exports) of High income: nonOECD and Exports(as % of merchandise exports) of Uganda?
Offer a terse response. 36.92. In the year 2009, what is the difference between the Exports(as % of merchandise exports) of Panama and Exports(as % of merchandise exports) of Rwanda?
Give a very brief answer. 0.87. In the year 2009, what is the difference between the Exports(as % of merchandise exports) in Panama and Exports(as % of merchandise exports) in Uganda?
Your response must be concise. -0.46. In the year 2009, what is the difference between the Exports(as % of merchandise exports) of Rwanda and Exports(as % of merchandise exports) of Uganda?
Offer a very short reply. -1.33. In the year 2010, what is the difference between the Exports(as % of merchandise exports) in High income: nonOECD and Exports(as % of merchandise exports) in Panama?
Offer a very short reply. 41.39. In the year 2010, what is the difference between the Exports(as % of merchandise exports) of High income: nonOECD and Exports(as % of merchandise exports) of Rwanda?
Make the answer very short. 41.7. In the year 2010, what is the difference between the Exports(as % of merchandise exports) in High income: nonOECD and Exports(as % of merchandise exports) in Uganda?
Provide a short and direct response. 40.5. In the year 2010, what is the difference between the Exports(as % of merchandise exports) of Panama and Exports(as % of merchandise exports) of Rwanda?
Ensure brevity in your answer.  0.31. In the year 2010, what is the difference between the Exports(as % of merchandise exports) of Panama and Exports(as % of merchandise exports) of Uganda?
Make the answer very short. -0.9. In the year 2010, what is the difference between the Exports(as % of merchandise exports) of Rwanda and Exports(as % of merchandise exports) of Uganda?
Give a very brief answer. -1.2. In the year 2011, what is the difference between the Exports(as % of merchandise exports) of High income: nonOECD and Exports(as % of merchandise exports) of Panama?
Give a very brief answer. 41.59. In the year 2011, what is the difference between the Exports(as % of merchandise exports) of High income: nonOECD and Exports(as % of merchandise exports) of Rwanda?
Ensure brevity in your answer.  41.57. In the year 2011, what is the difference between the Exports(as % of merchandise exports) in High income: nonOECD and Exports(as % of merchandise exports) in Uganda?
Your answer should be compact. 35.83. In the year 2011, what is the difference between the Exports(as % of merchandise exports) of Panama and Exports(as % of merchandise exports) of Rwanda?
Your response must be concise. -0.02. In the year 2011, what is the difference between the Exports(as % of merchandise exports) in Panama and Exports(as % of merchandise exports) in Uganda?
Your answer should be very brief. -5.76. In the year 2011, what is the difference between the Exports(as % of merchandise exports) of Rwanda and Exports(as % of merchandise exports) of Uganda?
Give a very brief answer. -5.74. What is the ratio of the Exports(as % of merchandise exports) in High income: nonOECD in 2005 to that in 2006?
Make the answer very short. 0.97. What is the ratio of the Exports(as % of merchandise exports) in Panama in 2005 to that in 2006?
Make the answer very short. 0.95. What is the ratio of the Exports(as % of merchandise exports) of Rwanda in 2005 to that in 2006?
Give a very brief answer. 3.19. What is the ratio of the Exports(as % of merchandise exports) of Uganda in 2005 to that in 2006?
Give a very brief answer. 0.37. What is the ratio of the Exports(as % of merchandise exports) of High income: nonOECD in 2005 to that in 2007?
Keep it short and to the point. 0.98. What is the ratio of the Exports(as % of merchandise exports) of Panama in 2005 to that in 2007?
Offer a terse response. 1.08. What is the ratio of the Exports(as % of merchandise exports) of Rwanda in 2005 to that in 2007?
Provide a short and direct response. 1.14. What is the ratio of the Exports(as % of merchandise exports) of Uganda in 2005 to that in 2007?
Provide a succinct answer. 1.35. What is the ratio of the Exports(as % of merchandise exports) in High income: nonOECD in 2005 to that in 2008?
Provide a short and direct response. 0.89. What is the ratio of the Exports(as % of merchandise exports) of Panama in 2005 to that in 2008?
Give a very brief answer. 1.13. What is the ratio of the Exports(as % of merchandise exports) in Rwanda in 2005 to that in 2008?
Your answer should be very brief. 0.03. What is the ratio of the Exports(as % of merchandise exports) of Uganda in 2005 to that in 2008?
Offer a very short reply. 1.45. What is the ratio of the Exports(as % of merchandise exports) of High income: nonOECD in 2005 to that in 2009?
Keep it short and to the point. 0.96. What is the ratio of the Exports(as % of merchandise exports) in Panama in 2005 to that in 2009?
Offer a very short reply. 0.81. What is the ratio of the Exports(as % of merchandise exports) in Rwanda in 2005 to that in 2009?
Provide a short and direct response. 0.26. What is the ratio of the Exports(as % of merchandise exports) in Uganda in 2005 to that in 2009?
Your answer should be very brief. 1.35. What is the ratio of the Exports(as % of merchandise exports) in High income: nonOECD in 2005 to that in 2010?
Offer a very short reply. 0.88. What is the ratio of the Exports(as % of merchandise exports) of Panama in 2005 to that in 2010?
Your answer should be compact. 2.35. What is the ratio of the Exports(as % of merchandise exports) of Rwanda in 2005 to that in 2010?
Give a very brief answer. 2.36. What is the ratio of the Exports(as % of merchandise exports) in Uganda in 2005 to that in 2010?
Make the answer very short. 1.54. What is the ratio of the Exports(as % of merchandise exports) in High income: nonOECD in 2005 to that in 2011?
Provide a short and direct response. 0.89. What is the ratio of the Exports(as % of merchandise exports) of Panama in 2005 to that in 2011?
Your answer should be compact. 58.29. What is the ratio of the Exports(as % of merchandise exports) in Rwanda in 2005 to that in 2011?
Provide a short and direct response. 0.41. What is the ratio of the Exports(as % of merchandise exports) of Uganda in 2005 to that in 2011?
Keep it short and to the point. 0.32. What is the ratio of the Exports(as % of merchandise exports) of High income: nonOECD in 2006 to that in 2007?
Provide a short and direct response. 1.01. What is the ratio of the Exports(as % of merchandise exports) of Panama in 2006 to that in 2007?
Offer a terse response. 1.14. What is the ratio of the Exports(as % of merchandise exports) of Rwanda in 2006 to that in 2007?
Ensure brevity in your answer.  0.36. What is the ratio of the Exports(as % of merchandise exports) in Uganda in 2006 to that in 2007?
Your answer should be compact. 3.65. What is the ratio of the Exports(as % of merchandise exports) of High income: nonOECD in 2006 to that in 2008?
Ensure brevity in your answer.  0.92. What is the ratio of the Exports(as % of merchandise exports) of Panama in 2006 to that in 2008?
Your answer should be very brief. 1.19. What is the ratio of the Exports(as % of merchandise exports) of Rwanda in 2006 to that in 2008?
Your response must be concise. 0.01. What is the ratio of the Exports(as % of merchandise exports) of Uganda in 2006 to that in 2008?
Your response must be concise. 3.93. What is the ratio of the Exports(as % of merchandise exports) of High income: nonOECD in 2006 to that in 2009?
Ensure brevity in your answer.  0.99. What is the ratio of the Exports(as % of merchandise exports) of Panama in 2006 to that in 2009?
Provide a short and direct response. 0.85. What is the ratio of the Exports(as % of merchandise exports) in Rwanda in 2006 to that in 2009?
Provide a succinct answer. 0.08. What is the ratio of the Exports(as % of merchandise exports) in Uganda in 2006 to that in 2009?
Give a very brief answer. 3.66. What is the ratio of the Exports(as % of merchandise exports) in High income: nonOECD in 2006 to that in 2010?
Provide a short and direct response. 0.91. What is the ratio of the Exports(as % of merchandise exports) in Panama in 2006 to that in 2010?
Provide a short and direct response. 2.47. What is the ratio of the Exports(as % of merchandise exports) in Rwanda in 2006 to that in 2010?
Make the answer very short. 0.74. What is the ratio of the Exports(as % of merchandise exports) of Uganda in 2006 to that in 2010?
Ensure brevity in your answer.  4.16. What is the ratio of the Exports(as % of merchandise exports) of High income: nonOECD in 2006 to that in 2011?
Ensure brevity in your answer.  0.91. What is the ratio of the Exports(as % of merchandise exports) of Panama in 2006 to that in 2011?
Provide a succinct answer. 61.23. What is the ratio of the Exports(as % of merchandise exports) in Rwanda in 2006 to that in 2011?
Provide a short and direct response. 0.13. What is the ratio of the Exports(as % of merchandise exports) in Uganda in 2006 to that in 2011?
Keep it short and to the point. 0.87. What is the ratio of the Exports(as % of merchandise exports) in High income: nonOECD in 2007 to that in 2008?
Your answer should be very brief. 0.9. What is the ratio of the Exports(as % of merchandise exports) of Panama in 2007 to that in 2008?
Your answer should be compact. 1.05. What is the ratio of the Exports(as % of merchandise exports) of Rwanda in 2007 to that in 2008?
Offer a terse response. 0.03. What is the ratio of the Exports(as % of merchandise exports) of Uganda in 2007 to that in 2008?
Provide a short and direct response. 1.08. What is the ratio of the Exports(as % of merchandise exports) in High income: nonOECD in 2007 to that in 2009?
Offer a terse response. 0.98. What is the ratio of the Exports(as % of merchandise exports) in Panama in 2007 to that in 2009?
Your response must be concise. 0.74. What is the ratio of the Exports(as % of merchandise exports) in Rwanda in 2007 to that in 2009?
Make the answer very short. 0.23. What is the ratio of the Exports(as % of merchandise exports) of Uganda in 2007 to that in 2009?
Ensure brevity in your answer.  1. What is the ratio of the Exports(as % of merchandise exports) of High income: nonOECD in 2007 to that in 2010?
Your answer should be very brief. 0.9. What is the ratio of the Exports(as % of merchandise exports) of Panama in 2007 to that in 2010?
Keep it short and to the point. 2.18. What is the ratio of the Exports(as % of merchandise exports) of Rwanda in 2007 to that in 2010?
Your answer should be very brief. 2.07. What is the ratio of the Exports(as % of merchandise exports) in Uganda in 2007 to that in 2010?
Ensure brevity in your answer.  1.14. What is the ratio of the Exports(as % of merchandise exports) of High income: nonOECD in 2007 to that in 2011?
Keep it short and to the point. 0.9. What is the ratio of the Exports(as % of merchandise exports) in Panama in 2007 to that in 2011?
Provide a short and direct response. 53.87. What is the ratio of the Exports(as % of merchandise exports) in Rwanda in 2007 to that in 2011?
Your answer should be very brief. 0.36. What is the ratio of the Exports(as % of merchandise exports) in Uganda in 2007 to that in 2011?
Provide a short and direct response. 0.24. What is the ratio of the Exports(as % of merchandise exports) in High income: nonOECD in 2008 to that in 2009?
Provide a short and direct response. 1.08. What is the ratio of the Exports(as % of merchandise exports) of Panama in 2008 to that in 2009?
Make the answer very short. 0.71. What is the ratio of the Exports(as % of merchandise exports) in Rwanda in 2008 to that in 2009?
Give a very brief answer. 8.01. What is the ratio of the Exports(as % of merchandise exports) in Uganda in 2008 to that in 2009?
Make the answer very short. 0.93. What is the ratio of the Exports(as % of merchandise exports) in High income: nonOECD in 2008 to that in 2010?
Keep it short and to the point. 0.99. What is the ratio of the Exports(as % of merchandise exports) in Panama in 2008 to that in 2010?
Offer a terse response. 2.08. What is the ratio of the Exports(as % of merchandise exports) of Rwanda in 2008 to that in 2010?
Make the answer very short. 71.41. What is the ratio of the Exports(as % of merchandise exports) of Uganda in 2008 to that in 2010?
Ensure brevity in your answer.  1.06. What is the ratio of the Exports(as % of merchandise exports) of Panama in 2008 to that in 2011?
Make the answer very short. 51.46. What is the ratio of the Exports(as % of merchandise exports) in Rwanda in 2008 to that in 2011?
Ensure brevity in your answer.  12.3. What is the ratio of the Exports(as % of merchandise exports) in Uganda in 2008 to that in 2011?
Give a very brief answer. 0.22. What is the ratio of the Exports(as % of merchandise exports) in High income: nonOECD in 2009 to that in 2010?
Give a very brief answer. 0.92. What is the ratio of the Exports(as % of merchandise exports) of Panama in 2009 to that in 2010?
Your answer should be compact. 2.92. What is the ratio of the Exports(as % of merchandise exports) in Rwanda in 2009 to that in 2010?
Give a very brief answer. 8.91. What is the ratio of the Exports(as % of merchandise exports) of Uganda in 2009 to that in 2010?
Offer a terse response. 1.14. What is the ratio of the Exports(as % of merchandise exports) of High income: nonOECD in 2009 to that in 2011?
Keep it short and to the point. 0.92. What is the ratio of the Exports(as % of merchandise exports) of Panama in 2009 to that in 2011?
Provide a succinct answer. 72.34. What is the ratio of the Exports(as % of merchandise exports) of Rwanda in 2009 to that in 2011?
Keep it short and to the point. 1.54. What is the ratio of the Exports(as % of merchandise exports) of Uganda in 2009 to that in 2011?
Your answer should be very brief. 0.24. What is the ratio of the Exports(as % of merchandise exports) of Panama in 2010 to that in 2011?
Offer a terse response. 24.76. What is the ratio of the Exports(as % of merchandise exports) of Rwanda in 2010 to that in 2011?
Your response must be concise. 0.17. What is the ratio of the Exports(as % of merchandise exports) of Uganda in 2010 to that in 2011?
Make the answer very short. 0.21. What is the difference between the highest and the second highest Exports(as % of merchandise exports) in High income: nonOECD?
Your response must be concise. 0.11. What is the difference between the highest and the second highest Exports(as % of merchandise exports) in Panama?
Give a very brief answer. 0.14. What is the difference between the highest and the second highest Exports(as % of merchandise exports) of Rwanda?
Ensure brevity in your answer.  0.33. What is the difference between the highest and the second highest Exports(as % of merchandise exports) in Uganda?
Your answer should be compact. 0.74. What is the difference between the highest and the lowest Exports(as % of merchandise exports) of High income: nonOECD?
Ensure brevity in your answer.  4.82. What is the difference between the highest and the lowest Exports(as % of merchandise exports) in Panama?
Make the answer very short. 0.9. What is the difference between the highest and the lowest Exports(as % of merchandise exports) of Rwanda?
Your answer should be compact. 0.37. What is the difference between the highest and the lowest Exports(as % of merchandise exports) of Uganda?
Offer a very short reply. 4.56. 